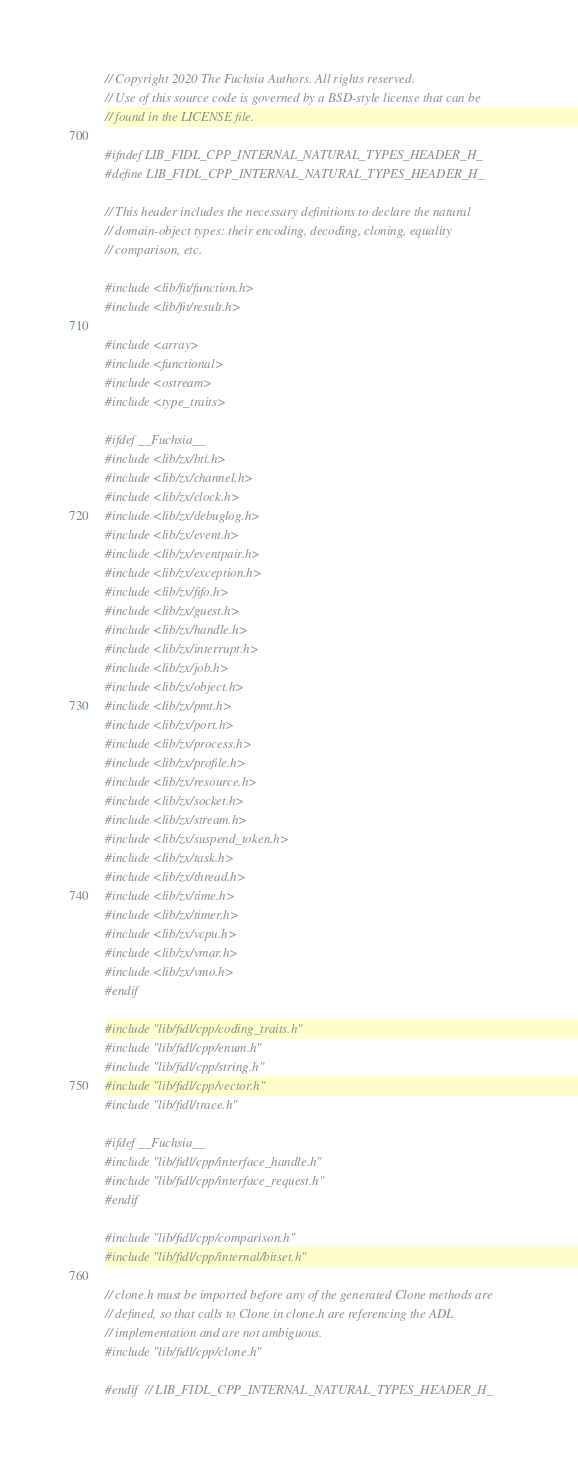<code> <loc_0><loc_0><loc_500><loc_500><_C_>// Copyright 2020 The Fuchsia Authors. All rights reserved.
// Use of this source code is governed by a BSD-style license that can be
// found in the LICENSE file.

#ifndef LIB_FIDL_CPP_INTERNAL_NATURAL_TYPES_HEADER_H_
#define LIB_FIDL_CPP_INTERNAL_NATURAL_TYPES_HEADER_H_

// This header includes the necessary definitions to declare the natural
// domain-object types: their encoding, decoding, cloning, equality
// comparison, etc.

#include <lib/fit/function.h>
#include <lib/fit/result.h>

#include <array>
#include <functional>
#include <ostream>
#include <type_traits>

#ifdef __Fuchsia__
#include <lib/zx/bti.h>
#include <lib/zx/channel.h>
#include <lib/zx/clock.h>
#include <lib/zx/debuglog.h>
#include <lib/zx/event.h>
#include <lib/zx/eventpair.h>
#include <lib/zx/exception.h>
#include <lib/zx/fifo.h>
#include <lib/zx/guest.h>
#include <lib/zx/handle.h>
#include <lib/zx/interrupt.h>
#include <lib/zx/job.h>
#include <lib/zx/object.h>
#include <lib/zx/pmt.h>
#include <lib/zx/port.h>
#include <lib/zx/process.h>
#include <lib/zx/profile.h>
#include <lib/zx/resource.h>
#include <lib/zx/socket.h>
#include <lib/zx/stream.h>
#include <lib/zx/suspend_token.h>
#include <lib/zx/task.h>
#include <lib/zx/thread.h>
#include <lib/zx/time.h>
#include <lib/zx/timer.h>
#include <lib/zx/vcpu.h>
#include <lib/zx/vmar.h>
#include <lib/zx/vmo.h>
#endif

#include "lib/fidl/cpp/coding_traits.h"
#include "lib/fidl/cpp/enum.h"
#include "lib/fidl/cpp/string.h"
#include "lib/fidl/cpp/vector.h"
#include "lib/fidl/trace.h"

#ifdef __Fuchsia__
#include "lib/fidl/cpp/interface_handle.h"
#include "lib/fidl/cpp/interface_request.h"
#endif

#include "lib/fidl/cpp/comparison.h"
#include "lib/fidl/cpp/internal/bitset.h"

// clone.h must be imported before any of the generated Clone methods are
// defined, so that calls to Clone in clone.h are referencing the ADL
// implementation and are not ambiguous.
#include "lib/fidl/cpp/clone.h"

#endif  // LIB_FIDL_CPP_INTERNAL_NATURAL_TYPES_HEADER_H_
</code> 